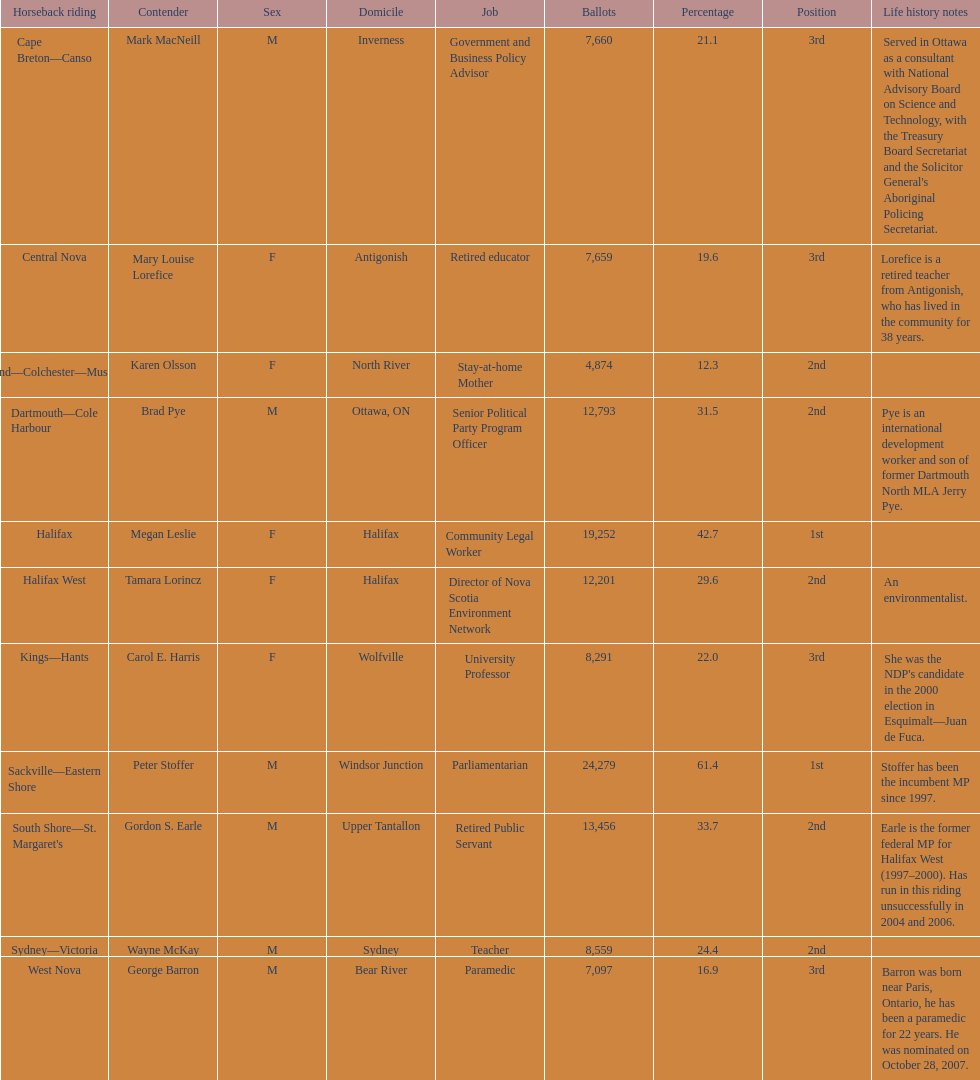Who got a larger number of votes, macneill or olsson? Mark MacNeill. 